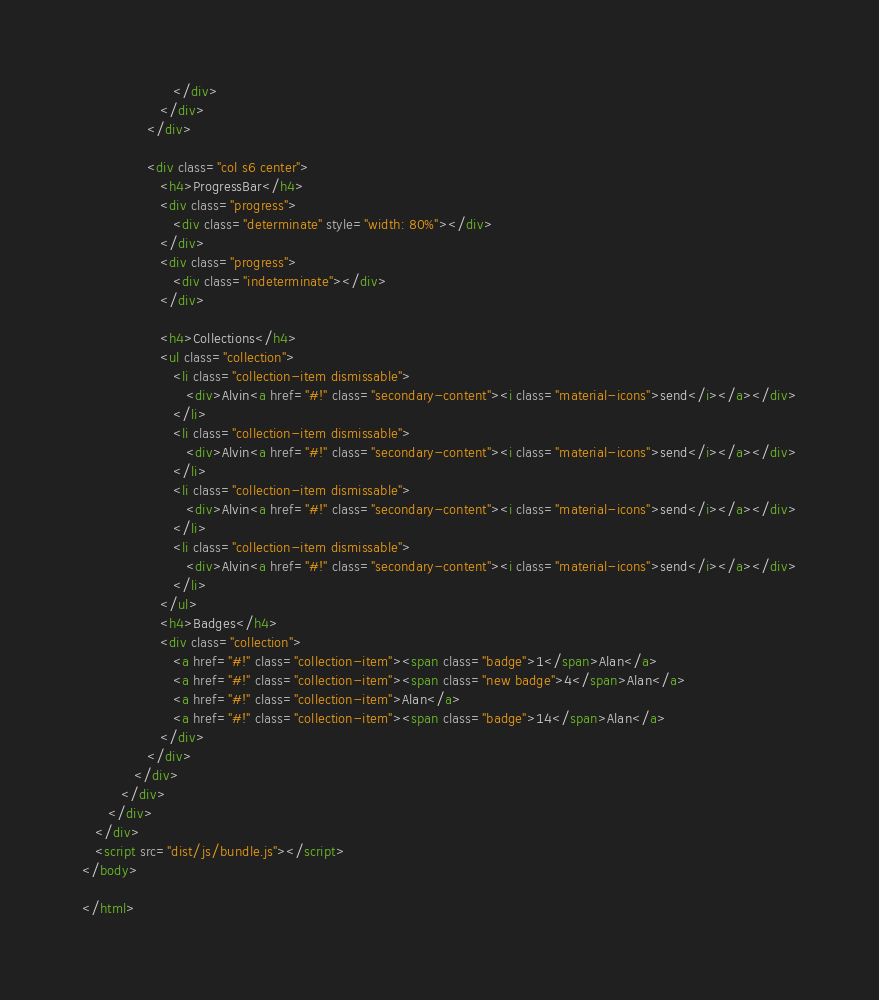<code> <loc_0><loc_0><loc_500><loc_500><_HTML_>                     </div>
                  </div>
               </div>

               <div class="col s6 center">
                  <h4>ProgressBar</h4>
                  <div class="progress">
                     <div class="determinate" style="width: 80%"></div>
                  </div>
                  <div class="progress">
                     <div class="indeterminate"></div>
                  </div>

                  <h4>Collections</h4>
                  <ul class="collection">
                     <li class="collection-item dismissable">
                        <div>Alvin<a href="#!" class="secondary-content"><i class="material-icons">send</i></a></div>
                     </li>
                     <li class="collection-item dismissable">
                        <div>Alvin<a href="#!" class="secondary-content"><i class="material-icons">send</i></a></div>
                     </li>
                     <li class="collection-item dismissable">
                        <div>Alvin<a href="#!" class="secondary-content"><i class="material-icons">send</i></a></div>
                     </li>
                     <li class="collection-item dismissable">
                        <div>Alvin<a href="#!" class="secondary-content"><i class="material-icons">send</i></a></div>
                     </li>
                  </ul>
                  <h4>Badges</h4>
                  <div class="collection">
                     <a href="#!" class="collection-item"><span class="badge">1</span>Alan</a>
                     <a href="#!" class="collection-item"><span class="new badge">4</span>Alan</a>
                     <a href="#!" class="collection-item">Alan</a>
                     <a href="#!" class="collection-item"><span class="badge">14</span>Alan</a>
                  </div>
               </div>
            </div>
         </div>
      </div>
   </div>
   <script src="dist/js/bundle.js"></script>
</body>

</html>
</code> 